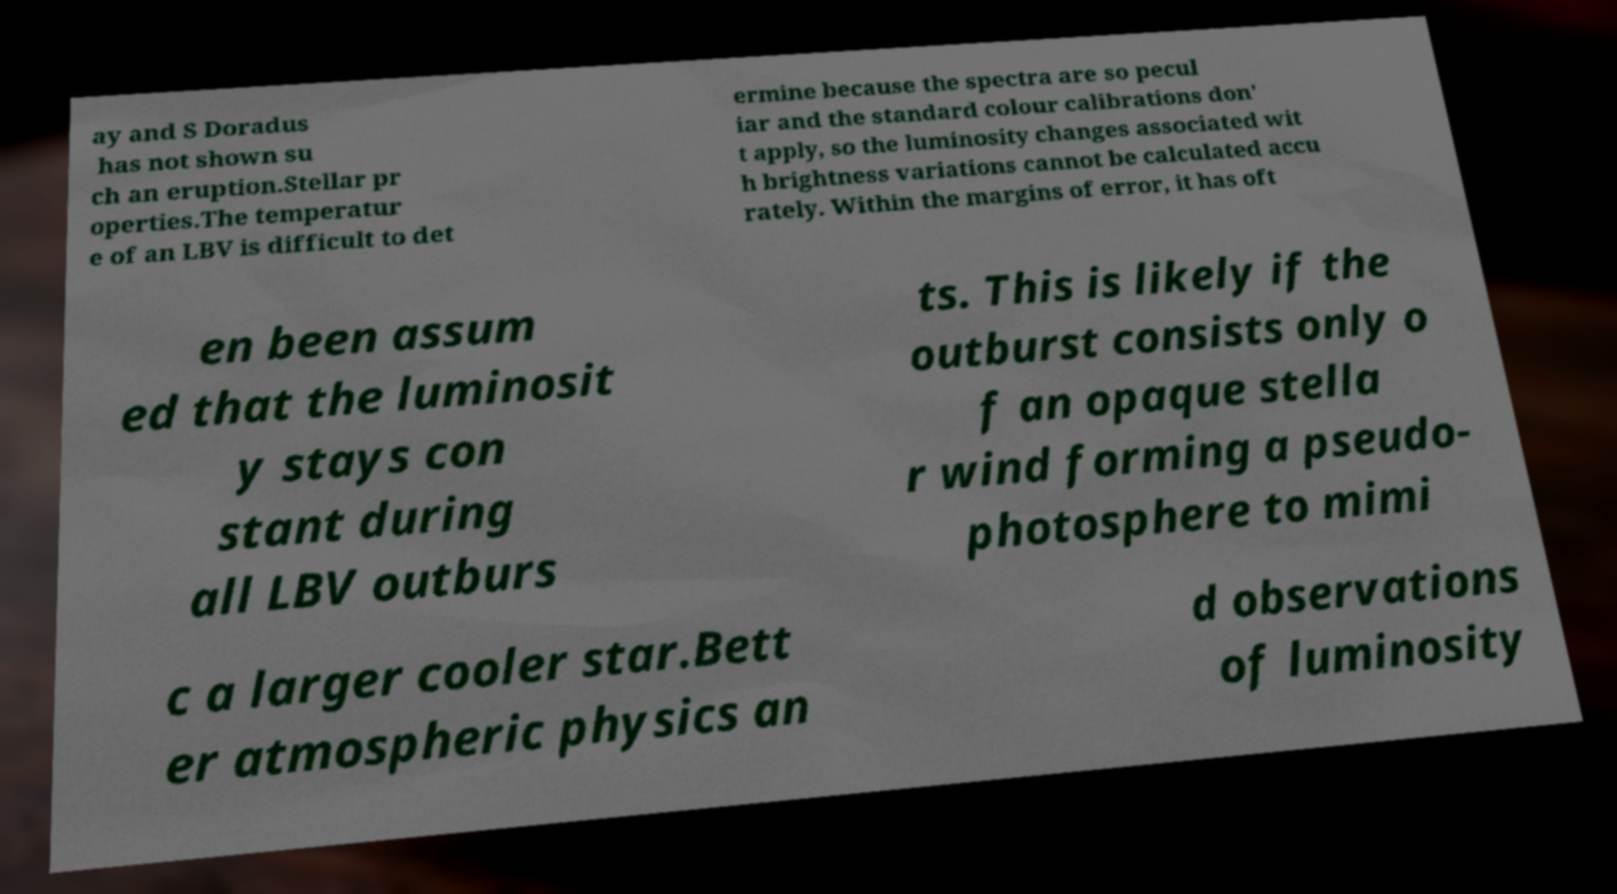Could you extract and type out the text from this image? ay and S Doradus has not shown su ch an eruption.Stellar pr operties.The temperatur e of an LBV is difficult to det ermine because the spectra are so pecul iar and the standard colour calibrations don' t apply, so the luminosity changes associated wit h brightness variations cannot be calculated accu rately. Within the margins of error, it has oft en been assum ed that the luminosit y stays con stant during all LBV outburs ts. This is likely if the outburst consists only o f an opaque stella r wind forming a pseudo- photosphere to mimi c a larger cooler star.Bett er atmospheric physics an d observations of luminosity 